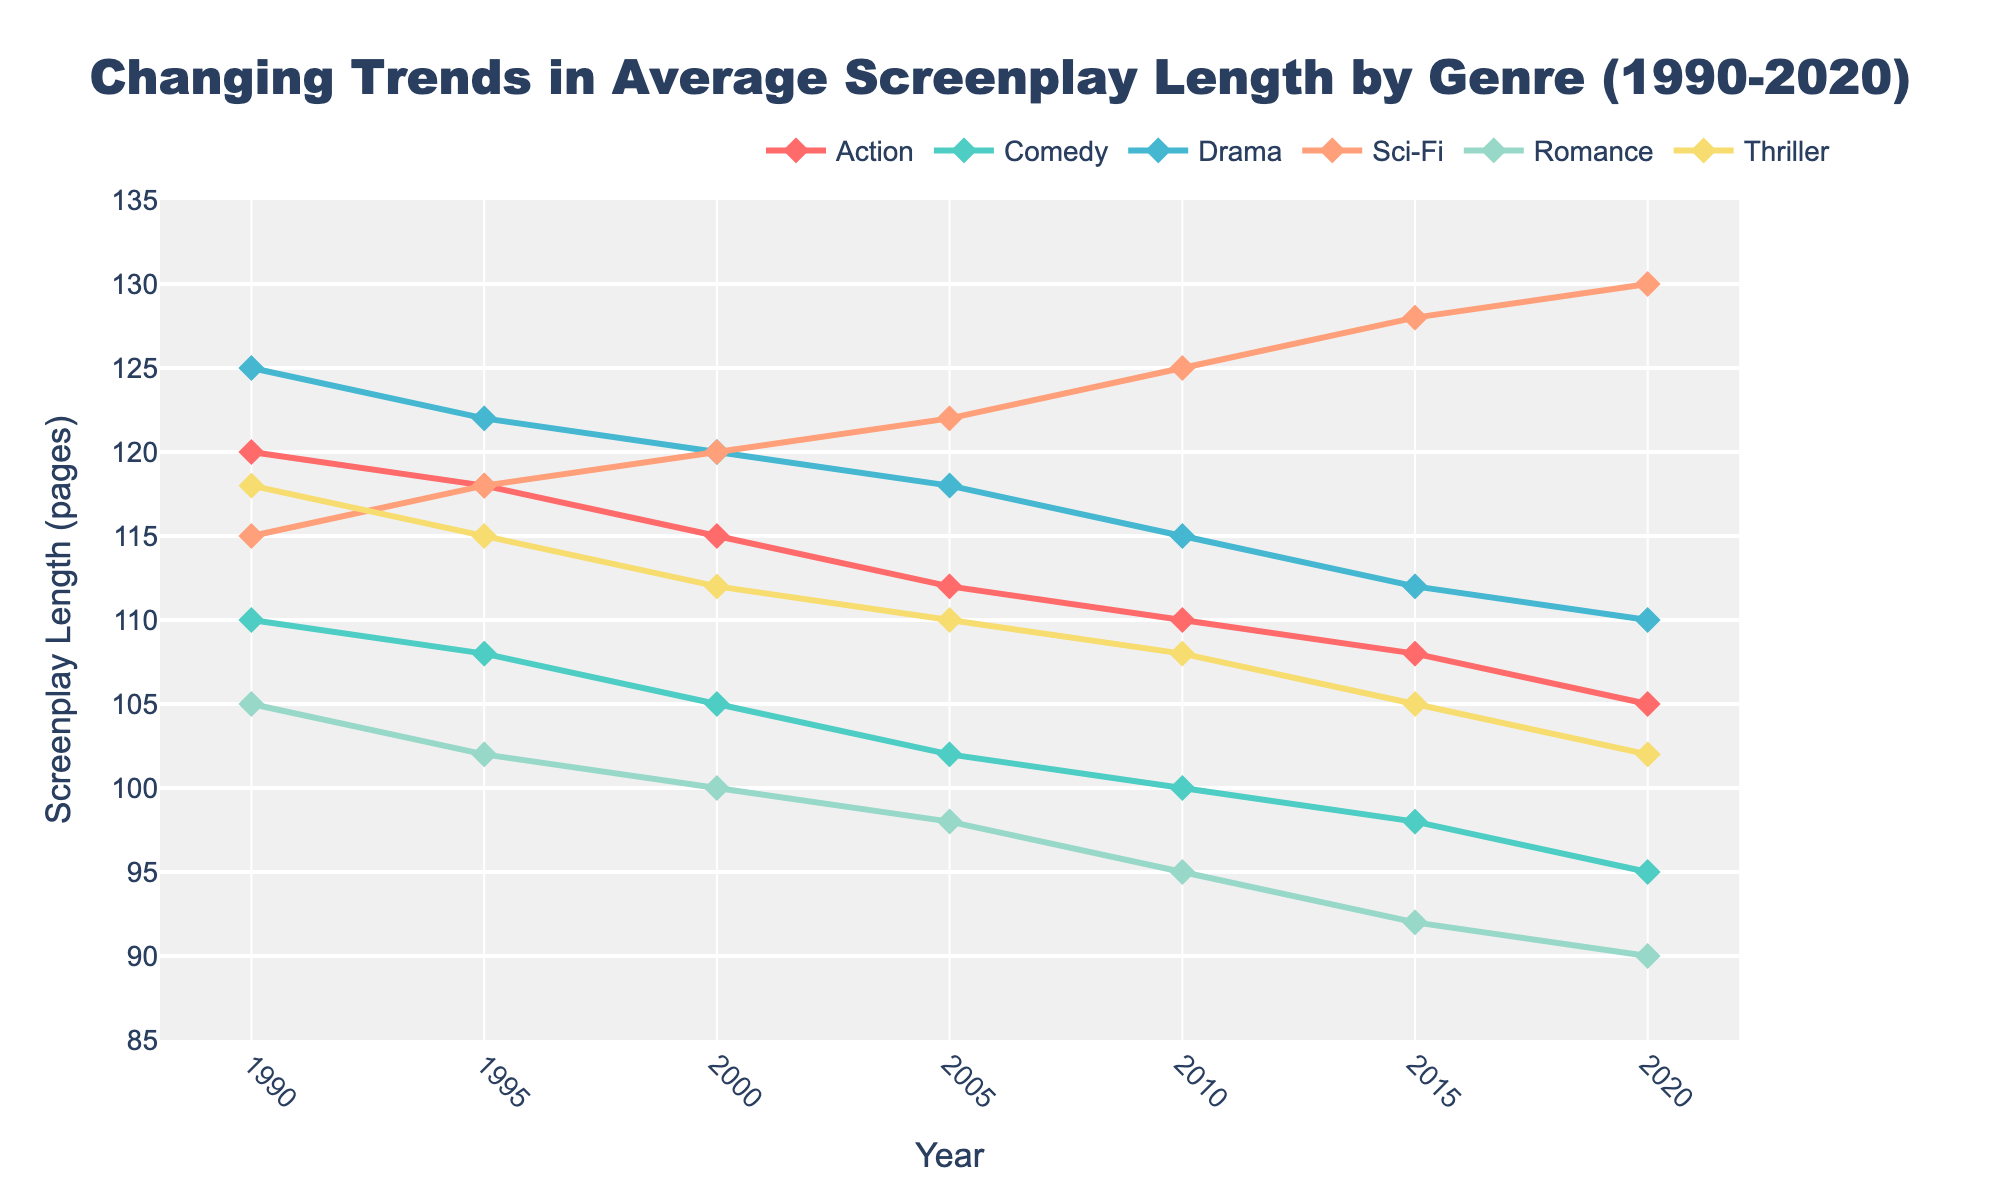What is the general trend of screenplay length for all genres over the last 30 years? The screenplay length shows a generally declining trend across all genres from 1990 to 2020. Each genre's line follows a downward slope through all the data points.
Answer: Declining Which genre had the longest average screenplay length in 2020? In 2020, the Sci-Fi genre had the longest average screenplay length. The purple line, representing Sci-Fi, is the highest above all other genres in that year.
Answer: Sci-Fi What is the difference in screenplay length for the Drama genre between 1990 and 2020? The screenplay length for Drama in 1990 is 125 pages and in 2020 is 110 pages. The difference is 125 - 110.
Answer: 15 pages Between 1995 and 2000, which genre saw the greatest decrease in screenplay length? The Action genre saw the largest decrease. It went from 118 pages in 1995 to 115 pages in 2000, reducing by 3 pages, while no other genre showed a large decrease during this period.
Answer: Action How does the average length of screenplays in the Romance genre in 2005 compare to the Thriller genre in the same year? In 2005, the Romance genre had a screenplay length of 98 pages, while the Thriller genre had 110 pages. The Thriller genre is longer by 12 pages.
Answer: Thriller is 12 pages longer In which year did the Comedy and Action genres have the same screenplay length, and what was it? In 2020, both Comedy and Action had screenplay lengths of 105 pages. They are represented by overlapping points in the final year on the chart.
Answer: 2020, 105 pages Of all the genres, which one has shown the most consistent decline in screenplay length without any increases over the 30 years? The Romance genre has consistently declined from 105 pages in 1990 to 90 pages in 2020 without any years of increase.
Answer: Romance What is the range of screenplay lengths for the Sci-Fi genre over the last 30 years? The highest screenplay length for Sci-Fi is 130 pages in 2020, and the lowest is 115 pages in 1990. The range is 130 - 115.
Answer: 15 pages Which genre had the shortest average screenplay length in 1995 and what was it? In 1995, the Romance genre had the shortest average screenplay length with 102 pages.
Answer: Romance, 102 pages 